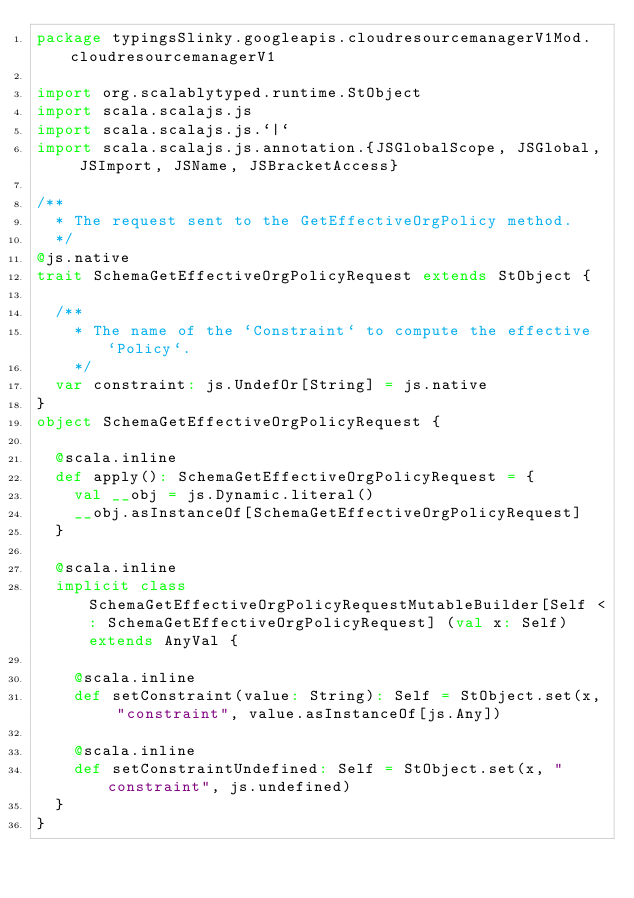<code> <loc_0><loc_0><loc_500><loc_500><_Scala_>package typingsSlinky.googleapis.cloudresourcemanagerV1Mod.cloudresourcemanagerV1

import org.scalablytyped.runtime.StObject
import scala.scalajs.js
import scala.scalajs.js.`|`
import scala.scalajs.js.annotation.{JSGlobalScope, JSGlobal, JSImport, JSName, JSBracketAccess}

/**
  * The request sent to the GetEffectiveOrgPolicy method.
  */
@js.native
trait SchemaGetEffectiveOrgPolicyRequest extends StObject {
  
  /**
    * The name of the `Constraint` to compute the effective `Policy`.
    */
  var constraint: js.UndefOr[String] = js.native
}
object SchemaGetEffectiveOrgPolicyRequest {
  
  @scala.inline
  def apply(): SchemaGetEffectiveOrgPolicyRequest = {
    val __obj = js.Dynamic.literal()
    __obj.asInstanceOf[SchemaGetEffectiveOrgPolicyRequest]
  }
  
  @scala.inline
  implicit class SchemaGetEffectiveOrgPolicyRequestMutableBuilder[Self <: SchemaGetEffectiveOrgPolicyRequest] (val x: Self) extends AnyVal {
    
    @scala.inline
    def setConstraint(value: String): Self = StObject.set(x, "constraint", value.asInstanceOf[js.Any])
    
    @scala.inline
    def setConstraintUndefined: Self = StObject.set(x, "constraint", js.undefined)
  }
}
</code> 